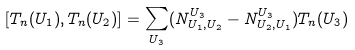Convert formula to latex. <formula><loc_0><loc_0><loc_500><loc_500>[ T _ { n } ( U _ { 1 } ) , T _ { n } ( U _ { 2 } ) ] = \sum _ { U _ { 3 } } ( N _ { U _ { 1 } , U _ { 2 } } ^ { U _ { 3 } } - N _ { U _ { 2 } , U _ { 1 } } ^ { U _ { 3 } } ) T _ { n } ( U _ { 3 } )</formula> 